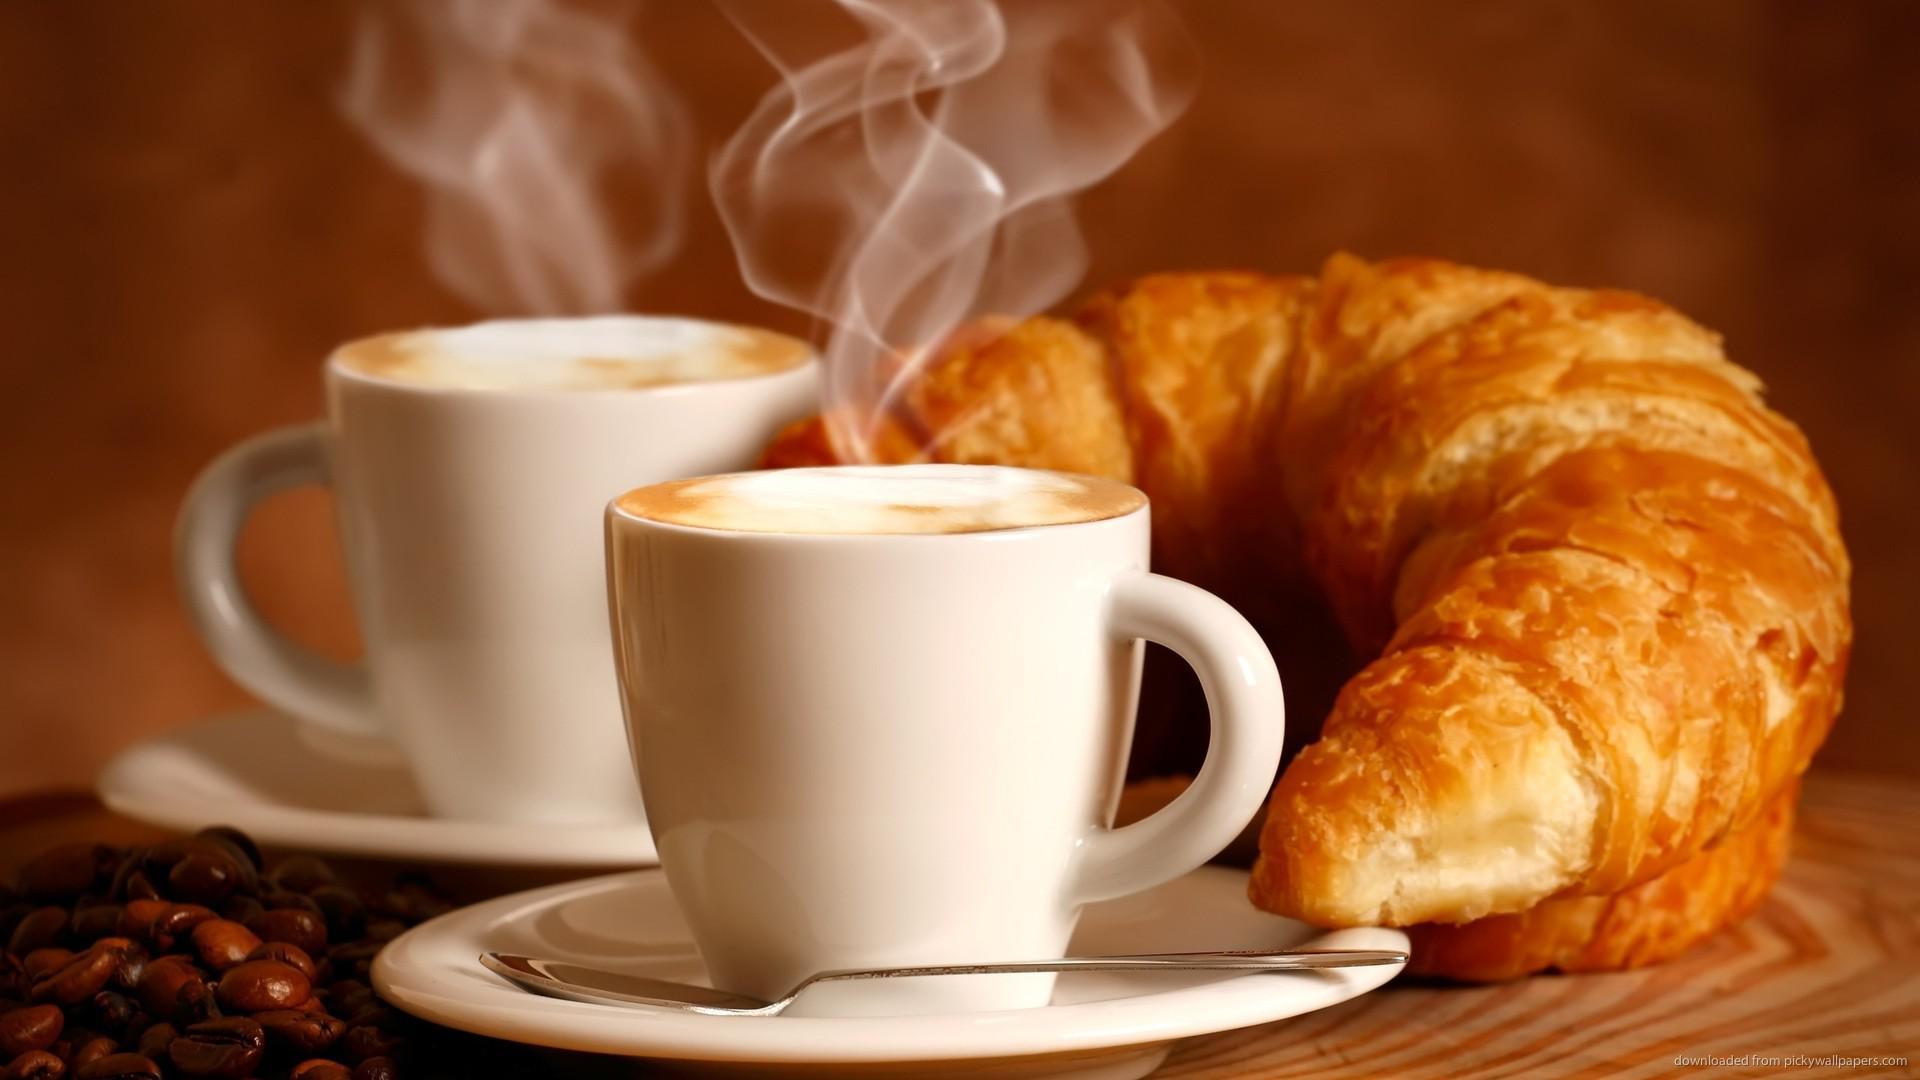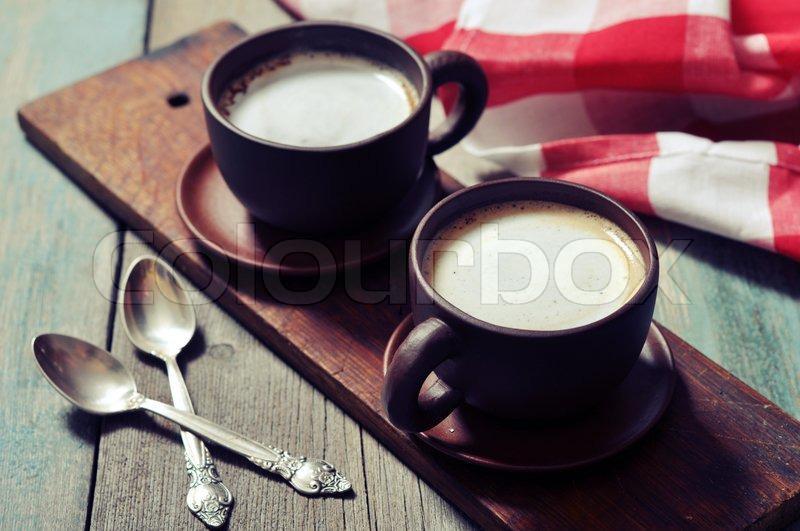The first image is the image on the left, the second image is the image on the right. Evaluate the accuracy of this statement regarding the images: "At least one of the images does not contain any brown wood.". Is it true? Answer yes or no. No. 